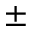Convert formula to latex. <formula><loc_0><loc_0><loc_500><loc_500>^ { \pm }</formula> 